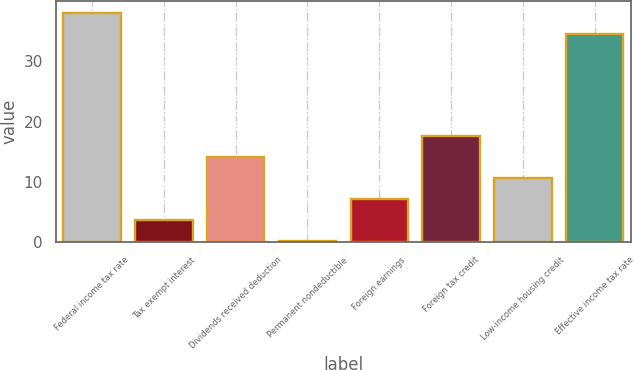Convert chart. <chart><loc_0><loc_0><loc_500><loc_500><bar_chart><fcel>Federal income tax rate<fcel>Tax exempt interest<fcel>Dividends received deduction<fcel>Permanent nondeductible<fcel>Foreign earnings<fcel>Foreign tax credit<fcel>Low-income housing credit<fcel>Effective income tax rate<nl><fcel>38.08<fcel>3.68<fcel>14.12<fcel>0.2<fcel>7.16<fcel>17.6<fcel>10.64<fcel>34.6<nl></chart> 